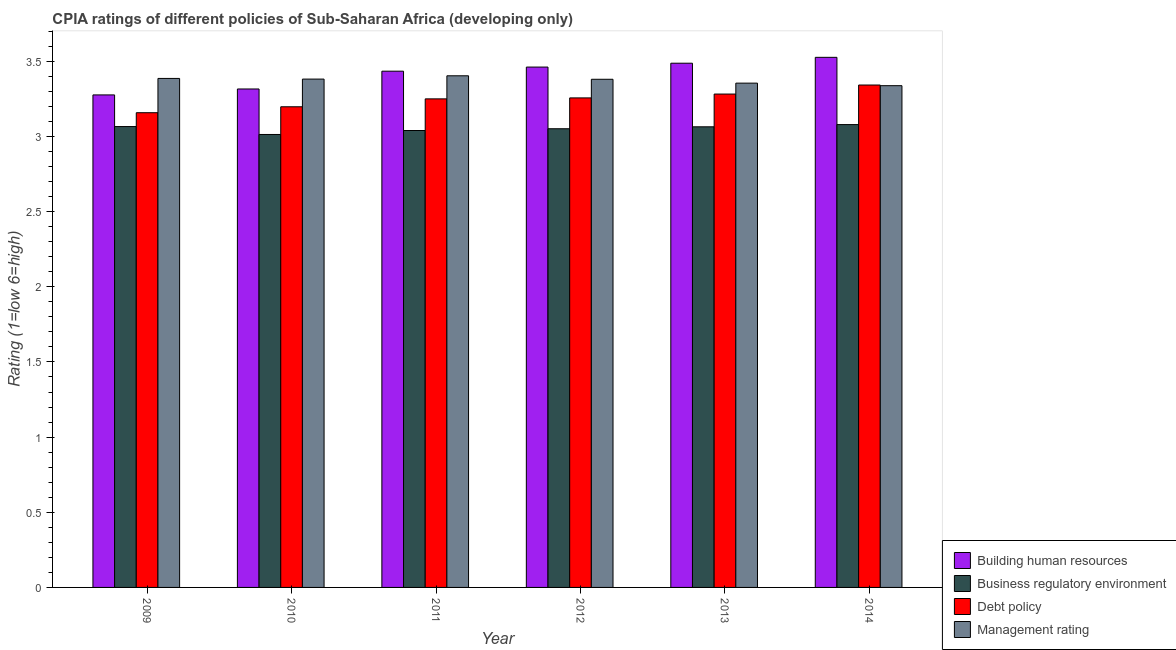How many groups of bars are there?
Provide a succinct answer. 6. Are the number of bars per tick equal to the number of legend labels?
Keep it short and to the point. Yes. How many bars are there on the 5th tick from the right?
Give a very brief answer. 4. What is the cpia rating of building human resources in 2013?
Keep it short and to the point. 3.49. Across all years, what is the maximum cpia rating of debt policy?
Provide a short and direct response. 3.34. Across all years, what is the minimum cpia rating of debt policy?
Keep it short and to the point. 3.16. In which year was the cpia rating of building human resources maximum?
Your answer should be very brief. 2014. In which year was the cpia rating of business regulatory environment minimum?
Offer a very short reply. 2010. What is the total cpia rating of debt policy in the graph?
Provide a succinct answer. 19.49. What is the difference between the cpia rating of building human resources in 2013 and that in 2014?
Keep it short and to the point. -0.04. What is the difference between the cpia rating of management in 2010 and the cpia rating of building human resources in 2011?
Your answer should be very brief. -0.02. What is the average cpia rating of business regulatory environment per year?
Give a very brief answer. 3.05. What is the ratio of the cpia rating of management in 2009 to that in 2014?
Your response must be concise. 1.01. Is the cpia rating of building human resources in 2012 less than that in 2014?
Keep it short and to the point. Yes. Is the difference between the cpia rating of building human resources in 2009 and 2014 greater than the difference between the cpia rating of business regulatory environment in 2009 and 2014?
Keep it short and to the point. No. What is the difference between the highest and the second highest cpia rating of management?
Keep it short and to the point. 0.02. What is the difference between the highest and the lowest cpia rating of debt policy?
Offer a terse response. 0.18. In how many years, is the cpia rating of management greater than the average cpia rating of management taken over all years?
Ensure brevity in your answer.  4. Is it the case that in every year, the sum of the cpia rating of business regulatory environment and cpia rating of management is greater than the sum of cpia rating of debt policy and cpia rating of building human resources?
Give a very brief answer. No. What does the 3rd bar from the left in 2013 represents?
Offer a very short reply. Debt policy. What does the 3rd bar from the right in 2011 represents?
Keep it short and to the point. Business regulatory environment. What is the difference between two consecutive major ticks on the Y-axis?
Make the answer very short. 0.5. Are the values on the major ticks of Y-axis written in scientific E-notation?
Your answer should be very brief. No. Does the graph contain any zero values?
Your answer should be very brief. No. Where does the legend appear in the graph?
Provide a short and direct response. Bottom right. What is the title of the graph?
Offer a very short reply. CPIA ratings of different policies of Sub-Saharan Africa (developing only). What is the label or title of the X-axis?
Your answer should be very brief. Year. What is the Rating (1=low 6=high) in Building human resources in 2009?
Provide a succinct answer. 3.28. What is the Rating (1=low 6=high) of Business regulatory environment in 2009?
Offer a terse response. 3.07. What is the Rating (1=low 6=high) of Debt policy in 2009?
Keep it short and to the point. 3.16. What is the Rating (1=low 6=high) of Management rating in 2009?
Make the answer very short. 3.39. What is the Rating (1=low 6=high) of Building human resources in 2010?
Make the answer very short. 3.32. What is the Rating (1=low 6=high) in Business regulatory environment in 2010?
Your response must be concise. 3.01. What is the Rating (1=low 6=high) of Debt policy in 2010?
Ensure brevity in your answer.  3.2. What is the Rating (1=low 6=high) of Management rating in 2010?
Offer a very short reply. 3.38. What is the Rating (1=low 6=high) in Building human resources in 2011?
Keep it short and to the point. 3.43. What is the Rating (1=low 6=high) in Business regulatory environment in 2011?
Offer a very short reply. 3.04. What is the Rating (1=low 6=high) in Debt policy in 2011?
Your answer should be compact. 3.25. What is the Rating (1=low 6=high) of Management rating in 2011?
Offer a very short reply. 3.4. What is the Rating (1=low 6=high) of Building human resources in 2012?
Provide a succinct answer. 3.46. What is the Rating (1=low 6=high) in Business regulatory environment in 2012?
Your response must be concise. 3.05. What is the Rating (1=low 6=high) of Debt policy in 2012?
Make the answer very short. 3.26. What is the Rating (1=low 6=high) in Management rating in 2012?
Provide a succinct answer. 3.38. What is the Rating (1=low 6=high) in Building human resources in 2013?
Your answer should be very brief. 3.49. What is the Rating (1=low 6=high) in Business regulatory environment in 2013?
Ensure brevity in your answer.  3.06. What is the Rating (1=low 6=high) in Debt policy in 2013?
Your response must be concise. 3.28. What is the Rating (1=low 6=high) in Management rating in 2013?
Ensure brevity in your answer.  3.35. What is the Rating (1=low 6=high) of Building human resources in 2014?
Keep it short and to the point. 3.53. What is the Rating (1=low 6=high) in Business regulatory environment in 2014?
Offer a very short reply. 3.08. What is the Rating (1=low 6=high) in Debt policy in 2014?
Provide a short and direct response. 3.34. What is the Rating (1=low 6=high) in Management rating in 2014?
Provide a short and direct response. 3.34. Across all years, what is the maximum Rating (1=low 6=high) in Building human resources?
Make the answer very short. 3.53. Across all years, what is the maximum Rating (1=low 6=high) in Business regulatory environment?
Your response must be concise. 3.08. Across all years, what is the maximum Rating (1=low 6=high) of Debt policy?
Keep it short and to the point. 3.34. Across all years, what is the maximum Rating (1=low 6=high) of Management rating?
Your answer should be compact. 3.4. Across all years, what is the minimum Rating (1=low 6=high) of Building human resources?
Your answer should be compact. 3.28. Across all years, what is the minimum Rating (1=low 6=high) of Business regulatory environment?
Keep it short and to the point. 3.01. Across all years, what is the minimum Rating (1=low 6=high) in Debt policy?
Give a very brief answer. 3.16. Across all years, what is the minimum Rating (1=low 6=high) in Management rating?
Make the answer very short. 3.34. What is the total Rating (1=low 6=high) of Building human resources in the graph?
Your answer should be very brief. 20.5. What is the total Rating (1=low 6=high) of Business regulatory environment in the graph?
Offer a very short reply. 18.31. What is the total Rating (1=low 6=high) of Debt policy in the graph?
Offer a terse response. 19.49. What is the total Rating (1=low 6=high) in Management rating in the graph?
Offer a terse response. 20.24. What is the difference between the Rating (1=low 6=high) in Building human resources in 2009 and that in 2010?
Ensure brevity in your answer.  -0.04. What is the difference between the Rating (1=low 6=high) of Business regulatory environment in 2009 and that in 2010?
Provide a short and direct response. 0.05. What is the difference between the Rating (1=low 6=high) of Debt policy in 2009 and that in 2010?
Ensure brevity in your answer.  -0.04. What is the difference between the Rating (1=low 6=high) of Management rating in 2009 and that in 2010?
Provide a succinct answer. 0. What is the difference between the Rating (1=low 6=high) of Building human resources in 2009 and that in 2011?
Your response must be concise. -0.16. What is the difference between the Rating (1=low 6=high) in Business regulatory environment in 2009 and that in 2011?
Your answer should be compact. 0.03. What is the difference between the Rating (1=low 6=high) in Debt policy in 2009 and that in 2011?
Offer a very short reply. -0.09. What is the difference between the Rating (1=low 6=high) of Management rating in 2009 and that in 2011?
Offer a terse response. -0.02. What is the difference between the Rating (1=low 6=high) of Building human resources in 2009 and that in 2012?
Your answer should be very brief. -0.19. What is the difference between the Rating (1=low 6=high) in Business regulatory environment in 2009 and that in 2012?
Keep it short and to the point. 0.01. What is the difference between the Rating (1=low 6=high) of Debt policy in 2009 and that in 2012?
Keep it short and to the point. -0.1. What is the difference between the Rating (1=low 6=high) of Management rating in 2009 and that in 2012?
Offer a very short reply. 0.01. What is the difference between the Rating (1=low 6=high) of Building human resources in 2009 and that in 2013?
Make the answer very short. -0.21. What is the difference between the Rating (1=low 6=high) in Business regulatory environment in 2009 and that in 2013?
Provide a succinct answer. 0. What is the difference between the Rating (1=low 6=high) in Debt policy in 2009 and that in 2013?
Ensure brevity in your answer.  -0.12. What is the difference between the Rating (1=low 6=high) of Management rating in 2009 and that in 2013?
Your answer should be very brief. 0.03. What is the difference between the Rating (1=low 6=high) of Business regulatory environment in 2009 and that in 2014?
Your answer should be compact. -0.01. What is the difference between the Rating (1=low 6=high) of Debt policy in 2009 and that in 2014?
Ensure brevity in your answer.  -0.18. What is the difference between the Rating (1=low 6=high) in Management rating in 2009 and that in 2014?
Offer a terse response. 0.05. What is the difference between the Rating (1=low 6=high) in Building human resources in 2010 and that in 2011?
Offer a terse response. -0.12. What is the difference between the Rating (1=low 6=high) of Business regulatory environment in 2010 and that in 2011?
Give a very brief answer. -0.03. What is the difference between the Rating (1=low 6=high) of Debt policy in 2010 and that in 2011?
Offer a very short reply. -0.05. What is the difference between the Rating (1=low 6=high) in Management rating in 2010 and that in 2011?
Offer a very short reply. -0.02. What is the difference between the Rating (1=low 6=high) of Building human resources in 2010 and that in 2012?
Offer a terse response. -0.15. What is the difference between the Rating (1=low 6=high) of Business regulatory environment in 2010 and that in 2012?
Give a very brief answer. -0.04. What is the difference between the Rating (1=low 6=high) in Debt policy in 2010 and that in 2012?
Your answer should be very brief. -0.06. What is the difference between the Rating (1=low 6=high) in Management rating in 2010 and that in 2012?
Ensure brevity in your answer.  0. What is the difference between the Rating (1=low 6=high) in Building human resources in 2010 and that in 2013?
Your answer should be compact. -0.17. What is the difference between the Rating (1=low 6=high) in Business regulatory environment in 2010 and that in 2013?
Give a very brief answer. -0.05. What is the difference between the Rating (1=low 6=high) of Debt policy in 2010 and that in 2013?
Your response must be concise. -0.08. What is the difference between the Rating (1=low 6=high) in Management rating in 2010 and that in 2013?
Keep it short and to the point. 0.03. What is the difference between the Rating (1=low 6=high) of Building human resources in 2010 and that in 2014?
Offer a terse response. -0.21. What is the difference between the Rating (1=low 6=high) of Business regulatory environment in 2010 and that in 2014?
Give a very brief answer. -0.07. What is the difference between the Rating (1=low 6=high) in Debt policy in 2010 and that in 2014?
Offer a very short reply. -0.14. What is the difference between the Rating (1=low 6=high) of Management rating in 2010 and that in 2014?
Keep it short and to the point. 0.04. What is the difference between the Rating (1=low 6=high) in Building human resources in 2011 and that in 2012?
Ensure brevity in your answer.  -0.03. What is the difference between the Rating (1=low 6=high) in Business regulatory environment in 2011 and that in 2012?
Your response must be concise. -0.01. What is the difference between the Rating (1=low 6=high) of Debt policy in 2011 and that in 2012?
Provide a succinct answer. -0.01. What is the difference between the Rating (1=low 6=high) of Management rating in 2011 and that in 2012?
Offer a very short reply. 0.02. What is the difference between the Rating (1=low 6=high) in Building human resources in 2011 and that in 2013?
Offer a very short reply. -0.05. What is the difference between the Rating (1=low 6=high) in Business regulatory environment in 2011 and that in 2013?
Your answer should be very brief. -0.02. What is the difference between the Rating (1=low 6=high) of Debt policy in 2011 and that in 2013?
Your answer should be very brief. -0.03. What is the difference between the Rating (1=low 6=high) in Management rating in 2011 and that in 2013?
Offer a terse response. 0.05. What is the difference between the Rating (1=low 6=high) in Building human resources in 2011 and that in 2014?
Offer a very short reply. -0.09. What is the difference between the Rating (1=low 6=high) in Business regulatory environment in 2011 and that in 2014?
Provide a short and direct response. -0.04. What is the difference between the Rating (1=low 6=high) in Debt policy in 2011 and that in 2014?
Keep it short and to the point. -0.09. What is the difference between the Rating (1=low 6=high) in Management rating in 2011 and that in 2014?
Make the answer very short. 0.07. What is the difference between the Rating (1=low 6=high) of Building human resources in 2012 and that in 2013?
Make the answer very short. -0.03. What is the difference between the Rating (1=low 6=high) of Business regulatory environment in 2012 and that in 2013?
Make the answer very short. -0.01. What is the difference between the Rating (1=low 6=high) in Debt policy in 2012 and that in 2013?
Offer a terse response. -0.03. What is the difference between the Rating (1=low 6=high) in Management rating in 2012 and that in 2013?
Provide a succinct answer. 0.03. What is the difference between the Rating (1=low 6=high) in Building human resources in 2012 and that in 2014?
Provide a short and direct response. -0.06. What is the difference between the Rating (1=low 6=high) in Business regulatory environment in 2012 and that in 2014?
Your answer should be compact. -0.03. What is the difference between the Rating (1=low 6=high) of Debt policy in 2012 and that in 2014?
Your answer should be compact. -0.09. What is the difference between the Rating (1=low 6=high) in Management rating in 2012 and that in 2014?
Keep it short and to the point. 0.04. What is the difference between the Rating (1=low 6=high) of Building human resources in 2013 and that in 2014?
Offer a terse response. -0.04. What is the difference between the Rating (1=low 6=high) of Business regulatory environment in 2013 and that in 2014?
Give a very brief answer. -0.01. What is the difference between the Rating (1=low 6=high) in Debt policy in 2013 and that in 2014?
Provide a succinct answer. -0.06. What is the difference between the Rating (1=low 6=high) in Management rating in 2013 and that in 2014?
Keep it short and to the point. 0.02. What is the difference between the Rating (1=low 6=high) in Building human resources in 2009 and the Rating (1=low 6=high) in Business regulatory environment in 2010?
Provide a short and direct response. 0.26. What is the difference between the Rating (1=low 6=high) of Building human resources in 2009 and the Rating (1=low 6=high) of Debt policy in 2010?
Provide a short and direct response. 0.08. What is the difference between the Rating (1=low 6=high) in Building human resources in 2009 and the Rating (1=low 6=high) in Management rating in 2010?
Provide a succinct answer. -0.11. What is the difference between the Rating (1=low 6=high) of Business regulatory environment in 2009 and the Rating (1=low 6=high) of Debt policy in 2010?
Offer a very short reply. -0.13. What is the difference between the Rating (1=low 6=high) in Business regulatory environment in 2009 and the Rating (1=low 6=high) in Management rating in 2010?
Your answer should be very brief. -0.32. What is the difference between the Rating (1=low 6=high) of Debt policy in 2009 and the Rating (1=low 6=high) of Management rating in 2010?
Your response must be concise. -0.22. What is the difference between the Rating (1=low 6=high) of Building human resources in 2009 and the Rating (1=low 6=high) of Business regulatory environment in 2011?
Make the answer very short. 0.24. What is the difference between the Rating (1=low 6=high) of Building human resources in 2009 and the Rating (1=low 6=high) of Debt policy in 2011?
Offer a terse response. 0.03. What is the difference between the Rating (1=low 6=high) of Building human resources in 2009 and the Rating (1=low 6=high) of Management rating in 2011?
Offer a very short reply. -0.13. What is the difference between the Rating (1=low 6=high) of Business regulatory environment in 2009 and the Rating (1=low 6=high) of Debt policy in 2011?
Provide a succinct answer. -0.18. What is the difference between the Rating (1=low 6=high) in Business regulatory environment in 2009 and the Rating (1=low 6=high) in Management rating in 2011?
Provide a succinct answer. -0.34. What is the difference between the Rating (1=low 6=high) in Debt policy in 2009 and the Rating (1=low 6=high) in Management rating in 2011?
Offer a very short reply. -0.25. What is the difference between the Rating (1=low 6=high) of Building human resources in 2009 and the Rating (1=low 6=high) of Business regulatory environment in 2012?
Provide a short and direct response. 0.23. What is the difference between the Rating (1=low 6=high) in Building human resources in 2009 and the Rating (1=low 6=high) in Debt policy in 2012?
Give a very brief answer. 0.02. What is the difference between the Rating (1=low 6=high) in Building human resources in 2009 and the Rating (1=low 6=high) in Management rating in 2012?
Provide a short and direct response. -0.1. What is the difference between the Rating (1=low 6=high) in Business regulatory environment in 2009 and the Rating (1=low 6=high) in Debt policy in 2012?
Offer a terse response. -0.19. What is the difference between the Rating (1=low 6=high) in Business regulatory environment in 2009 and the Rating (1=low 6=high) in Management rating in 2012?
Ensure brevity in your answer.  -0.31. What is the difference between the Rating (1=low 6=high) in Debt policy in 2009 and the Rating (1=low 6=high) in Management rating in 2012?
Provide a succinct answer. -0.22. What is the difference between the Rating (1=low 6=high) of Building human resources in 2009 and the Rating (1=low 6=high) of Business regulatory environment in 2013?
Provide a short and direct response. 0.21. What is the difference between the Rating (1=low 6=high) in Building human resources in 2009 and the Rating (1=low 6=high) in Debt policy in 2013?
Offer a terse response. -0.01. What is the difference between the Rating (1=low 6=high) in Building human resources in 2009 and the Rating (1=low 6=high) in Management rating in 2013?
Offer a terse response. -0.08. What is the difference between the Rating (1=low 6=high) of Business regulatory environment in 2009 and the Rating (1=low 6=high) of Debt policy in 2013?
Make the answer very short. -0.22. What is the difference between the Rating (1=low 6=high) in Business regulatory environment in 2009 and the Rating (1=low 6=high) in Management rating in 2013?
Ensure brevity in your answer.  -0.29. What is the difference between the Rating (1=low 6=high) in Debt policy in 2009 and the Rating (1=low 6=high) in Management rating in 2013?
Ensure brevity in your answer.  -0.2. What is the difference between the Rating (1=low 6=high) in Building human resources in 2009 and the Rating (1=low 6=high) in Business regulatory environment in 2014?
Your response must be concise. 0.2. What is the difference between the Rating (1=low 6=high) of Building human resources in 2009 and the Rating (1=low 6=high) of Debt policy in 2014?
Provide a succinct answer. -0.07. What is the difference between the Rating (1=low 6=high) in Building human resources in 2009 and the Rating (1=low 6=high) in Management rating in 2014?
Provide a succinct answer. -0.06. What is the difference between the Rating (1=low 6=high) of Business regulatory environment in 2009 and the Rating (1=low 6=high) of Debt policy in 2014?
Your response must be concise. -0.28. What is the difference between the Rating (1=low 6=high) of Business regulatory environment in 2009 and the Rating (1=low 6=high) of Management rating in 2014?
Your answer should be very brief. -0.27. What is the difference between the Rating (1=low 6=high) of Debt policy in 2009 and the Rating (1=low 6=high) of Management rating in 2014?
Your answer should be very brief. -0.18. What is the difference between the Rating (1=low 6=high) in Building human resources in 2010 and the Rating (1=low 6=high) in Business regulatory environment in 2011?
Keep it short and to the point. 0.28. What is the difference between the Rating (1=low 6=high) of Building human resources in 2010 and the Rating (1=low 6=high) of Debt policy in 2011?
Give a very brief answer. 0.07. What is the difference between the Rating (1=low 6=high) in Building human resources in 2010 and the Rating (1=low 6=high) in Management rating in 2011?
Make the answer very short. -0.09. What is the difference between the Rating (1=low 6=high) of Business regulatory environment in 2010 and the Rating (1=low 6=high) of Debt policy in 2011?
Your answer should be very brief. -0.24. What is the difference between the Rating (1=low 6=high) in Business regulatory environment in 2010 and the Rating (1=low 6=high) in Management rating in 2011?
Offer a very short reply. -0.39. What is the difference between the Rating (1=low 6=high) of Debt policy in 2010 and the Rating (1=low 6=high) of Management rating in 2011?
Ensure brevity in your answer.  -0.21. What is the difference between the Rating (1=low 6=high) of Building human resources in 2010 and the Rating (1=low 6=high) of Business regulatory environment in 2012?
Ensure brevity in your answer.  0.26. What is the difference between the Rating (1=low 6=high) of Building human resources in 2010 and the Rating (1=low 6=high) of Debt policy in 2012?
Offer a terse response. 0.06. What is the difference between the Rating (1=low 6=high) in Building human resources in 2010 and the Rating (1=low 6=high) in Management rating in 2012?
Give a very brief answer. -0.06. What is the difference between the Rating (1=low 6=high) of Business regulatory environment in 2010 and the Rating (1=low 6=high) of Debt policy in 2012?
Offer a very short reply. -0.24. What is the difference between the Rating (1=low 6=high) of Business regulatory environment in 2010 and the Rating (1=low 6=high) of Management rating in 2012?
Your answer should be very brief. -0.37. What is the difference between the Rating (1=low 6=high) of Debt policy in 2010 and the Rating (1=low 6=high) of Management rating in 2012?
Ensure brevity in your answer.  -0.18. What is the difference between the Rating (1=low 6=high) of Building human resources in 2010 and the Rating (1=low 6=high) of Business regulatory environment in 2013?
Provide a succinct answer. 0.25. What is the difference between the Rating (1=low 6=high) in Building human resources in 2010 and the Rating (1=low 6=high) in Debt policy in 2013?
Make the answer very short. 0.03. What is the difference between the Rating (1=low 6=high) in Building human resources in 2010 and the Rating (1=low 6=high) in Management rating in 2013?
Provide a short and direct response. -0.04. What is the difference between the Rating (1=low 6=high) of Business regulatory environment in 2010 and the Rating (1=low 6=high) of Debt policy in 2013?
Offer a very short reply. -0.27. What is the difference between the Rating (1=low 6=high) of Business regulatory environment in 2010 and the Rating (1=low 6=high) of Management rating in 2013?
Keep it short and to the point. -0.34. What is the difference between the Rating (1=low 6=high) of Debt policy in 2010 and the Rating (1=low 6=high) of Management rating in 2013?
Keep it short and to the point. -0.16. What is the difference between the Rating (1=low 6=high) of Building human resources in 2010 and the Rating (1=low 6=high) of Business regulatory environment in 2014?
Offer a very short reply. 0.24. What is the difference between the Rating (1=low 6=high) in Building human resources in 2010 and the Rating (1=low 6=high) in Debt policy in 2014?
Keep it short and to the point. -0.03. What is the difference between the Rating (1=low 6=high) in Building human resources in 2010 and the Rating (1=low 6=high) in Management rating in 2014?
Offer a terse response. -0.02. What is the difference between the Rating (1=low 6=high) in Business regulatory environment in 2010 and the Rating (1=low 6=high) in Debt policy in 2014?
Provide a short and direct response. -0.33. What is the difference between the Rating (1=low 6=high) in Business regulatory environment in 2010 and the Rating (1=low 6=high) in Management rating in 2014?
Your answer should be compact. -0.32. What is the difference between the Rating (1=low 6=high) in Debt policy in 2010 and the Rating (1=low 6=high) in Management rating in 2014?
Ensure brevity in your answer.  -0.14. What is the difference between the Rating (1=low 6=high) of Building human resources in 2011 and the Rating (1=low 6=high) of Business regulatory environment in 2012?
Keep it short and to the point. 0.38. What is the difference between the Rating (1=low 6=high) of Building human resources in 2011 and the Rating (1=low 6=high) of Debt policy in 2012?
Your answer should be very brief. 0.18. What is the difference between the Rating (1=low 6=high) of Building human resources in 2011 and the Rating (1=low 6=high) of Management rating in 2012?
Offer a terse response. 0.05. What is the difference between the Rating (1=low 6=high) of Business regulatory environment in 2011 and the Rating (1=low 6=high) of Debt policy in 2012?
Keep it short and to the point. -0.22. What is the difference between the Rating (1=low 6=high) in Business regulatory environment in 2011 and the Rating (1=low 6=high) in Management rating in 2012?
Provide a short and direct response. -0.34. What is the difference between the Rating (1=low 6=high) in Debt policy in 2011 and the Rating (1=low 6=high) in Management rating in 2012?
Offer a terse response. -0.13. What is the difference between the Rating (1=low 6=high) in Building human resources in 2011 and the Rating (1=low 6=high) in Business regulatory environment in 2013?
Your answer should be compact. 0.37. What is the difference between the Rating (1=low 6=high) of Building human resources in 2011 and the Rating (1=low 6=high) of Debt policy in 2013?
Your response must be concise. 0.15. What is the difference between the Rating (1=low 6=high) of Building human resources in 2011 and the Rating (1=low 6=high) of Management rating in 2013?
Provide a short and direct response. 0.08. What is the difference between the Rating (1=low 6=high) in Business regulatory environment in 2011 and the Rating (1=low 6=high) in Debt policy in 2013?
Give a very brief answer. -0.24. What is the difference between the Rating (1=low 6=high) in Business regulatory environment in 2011 and the Rating (1=low 6=high) in Management rating in 2013?
Your answer should be very brief. -0.32. What is the difference between the Rating (1=low 6=high) in Debt policy in 2011 and the Rating (1=low 6=high) in Management rating in 2013?
Your answer should be very brief. -0.1. What is the difference between the Rating (1=low 6=high) in Building human resources in 2011 and the Rating (1=low 6=high) in Business regulatory environment in 2014?
Offer a very short reply. 0.36. What is the difference between the Rating (1=low 6=high) in Building human resources in 2011 and the Rating (1=low 6=high) in Debt policy in 2014?
Provide a succinct answer. 0.09. What is the difference between the Rating (1=low 6=high) of Building human resources in 2011 and the Rating (1=low 6=high) of Management rating in 2014?
Your answer should be compact. 0.1. What is the difference between the Rating (1=low 6=high) in Business regulatory environment in 2011 and the Rating (1=low 6=high) in Debt policy in 2014?
Offer a very short reply. -0.3. What is the difference between the Rating (1=low 6=high) of Business regulatory environment in 2011 and the Rating (1=low 6=high) of Management rating in 2014?
Provide a succinct answer. -0.3. What is the difference between the Rating (1=low 6=high) in Debt policy in 2011 and the Rating (1=low 6=high) in Management rating in 2014?
Offer a terse response. -0.09. What is the difference between the Rating (1=low 6=high) of Building human resources in 2012 and the Rating (1=low 6=high) of Business regulatory environment in 2013?
Your answer should be very brief. 0.4. What is the difference between the Rating (1=low 6=high) of Building human resources in 2012 and the Rating (1=low 6=high) of Debt policy in 2013?
Offer a terse response. 0.18. What is the difference between the Rating (1=low 6=high) of Building human resources in 2012 and the Rating (1=low 6=high) of Management rating in 2013?
Your response must be concise. 0.11. What is the difference between the Rating (1=low 6=high) in Business regulatory environment in 2012 and the Rating (1=low 6=high) in Debt policy in 2013?
Your answer should be compact. -0.23. What is the difference between the Rating (1=low 6=high) in Business regulatory environment in 2012 and the Rating (1=low 6=high) in Management rating in 2013?
Ensure brevity in your answer.  -0.3. What is the difference between the Rating (1=low 6=high) of Debt policy in 2012 and the Rating (1=low 6=high) of Management rating in 2013?
Your answer should be compact. -0.1. What is the difference between the Rating (1=low 6=high) of Building human resources in 2012 and the Rating (1=low 6=high) of Business regulatory environment in 2014?
Provide a short and direct response. 0.38. What is the difference between the Rating (1=low 6=high) of Building human resources in 2012 and the Rating (1=low 6=high) of Debt policy in 2014?
Your response must be concise. 0.12. What is the difference between the Rating (1=low 6=high) in Building human resources in 2012 and the Rating (1=low 6=high) in Management rating in 2014?
Make the answer very short. 0.12. What is the difference between the Rating (1=low 6=high) of Business regulatory environment in 2012 and the Rating (1=low 6=high) of Debt policy in 2014?
Give a very brief answer. -0.29. What is the difference between the Rating (1=low 6=high) in Business regulatory environment in 2012 and the Rating (1=low 6=high) in Management rating in 2014?
Offer a terse response. -0.29. What is the difference between the Rating (1=low 6=high) of Debt policy in 2012 and the Rating (1=low 6=high) of Management rating in 2014?
Your answer should be very brief. -0.08. What is the difference between the Rating (1=low 6=high) in Building human resources in 2013 and the Rating (1=low 6=high) in Business regulatory environment in 2014?
Provide a succinct answer. 0.41. What is the difference between the Rating (1=low 6=high) of Building human resources in 2013 and the Rating (1=low 6=high) of Debt policy in 2014?
Provide a short and direct response. 0.15. What is the difference between the Rating (1=low 6=high) in Building human resources in 2013 and the Rating (1=low 6=high) in Management rating in 2014?
Your answer should be compact. 0.15. What is the difference between the Rating (1=low 6=high) in Business regulatory environment in 2013 and the Rating (1=low 6=high) in Debt policy in 2014?
Offer a terse response. -0.28. What is the difference between the Rating (1=low 6=high) in Business regulatory environment in 2013 and the Rating (1=low 6=high) in Management rating in 2014?
Keep it short and to the point. -0.27. What is the difference between the Rating (1=low 6=high) in Debt policy in 2013 and the Rating (1=low 6=high) in Management rating in 2014?
Offer a very short reply. -0.06. What is the average Rating (1=low 6=high) of Building human resources per year?
Make the answer very short. 3.42. What is the average Rating (1=low 6=high) in Business regulatory environment per year?
Offer a very short reply. 3.05. What is the average Rating (1=low 6=high) in Debt policy per year?
Provide a succinct answer. 3.25. What is the average Rating (1=low 6=high) of Management rating per year?
Make the answer very short. 3.37. In the year 2009, what is the difference between the Rating (1=low 6=high) of Building human resources and Rating (1=low 6=high) of Business regulatory environment?
Ensure brevity in your answer.  0.21. In the year 2009, what is the difference between the Rating (1=low 6=high) of Building human resources and Rating (1=low 6=high) of Debt policy?
Provide a short and direct response. 0.12. In the year 2009, what is the difference between the Rating (1=low 6=high) of Building human resources and Rating (1=low 6=high) of Management rating?
Your response must be concise. -0.11. In the year 2009, what is the difference between the Rating (1=low 6=high) in Business regulatory environment and Rating (1=low 6=high) in Debt policy?
Your answer should be very brief. -0.09. In the year 2009, what is the difference between the Rating (1=low 6=high) of Business regulatory environment and Rating (1=low 6=high) of Management rating?
Give a very brief answer. -0.32. In the year 2009, what is the difference between the Rating (1=low 6=high) of Debt policy and Rating (1=low 6=high) of Management rating?
Give a very brief answer. -0.23. In the year 2010, what is the difference between the Rating (1=low 6=high) of Building human resources and Rating (1=low 6=high) of Business regulatory environment?
Provide a succinct answer. 0.3. In the year 2010, what is the difference between the Rating (1=low 6=high) in Building human resources and Rating (1=low 6=high) in Debt policy?
Your response must be concise. 0.12. In the year 2010, what is the difference between the Rating (1=low 6=high) of Building human resources and Rating (1=low 6=high) of Management rating?
Provide a short and direct response. -0.07. In the year 2010, what is the difference between the Rating (1=low 6=high) of Business regulatory environment and Rating (1=low 6=high) of Debt policy?
Make the answer very short. -0.18. In the year 2010, what is the difference between the Rating (1=low 6=high) in Business regulatory environment and Rating (1=low 6=high) in Management rating?
Offer a terse response. -0.37. In the year 2010, what is the difference between the Rating (1=low 6=high) in Debt policy and Rating (1=low 6=high) in Management rating?
Your answer should be very brief. -0.18. In the year 2011, what is the difference between the Rating (1=low 6=high) in Building human resources and Rating (1=low 6=high) in Business regulatory environment?
Make the answer very short. 0.39. In the year 2011, what is the difference between the Rating (1=low 6=high) in Building human resources and Rating (1=low 6=high) in Debt policy?
Give a very brief answer. 0.18. In the year 2011, what is the difference between the Rating (1=low 6=high) of Building human resources and Rating (1=low 6=high) of Management rating?
Keep it short and to the point. 0.03. In the year 2011, what is the difference between the Rating (1=low 6=high) in Business regulatory environment and Rating (1=low 6=high) in Debt policy?
Provide a short and direct response. -0.21. In the year 2011, what is the difference between the Rating (1=low 6=high) of Business regulatory environment and Rating (1=low 6=high) of Management rating?
Keep it short and to the point. -0.36. In the year 2011, what is the difference between the Rating (1=low 6=high) in Debt policy and Rating (1=low 6=high) in Management rating?
Provide a succinct answer. -0.15. In the year 2012, what is the difference between the Rating (1=low 6=high) in Building human resources and Rating (1=low 6=high) in Business regulatory environment?
Your response must be concise. 0.41. In the year 2012, what is the difference between the Rating (1=low 6=high) of Building human resources and Rating (1=low 6=high) of Debt policy?
Make the answer very short. 0.21. In the year 2012, what is the difference between the Rating (1=low 6=high) in Building human resources and Rating (1=low 6=high) in Management rating?
Give a very brief answer. 0.08. In the year 2012, what is the difference between the Rating (1=low 6=high) of Business regulatory environment and Rating (1=low 6=high) of Debt policy?
Keep it short and to the point. -0.21. In the year 2012, what is the difference between the Rating (1=low 6=high) in Business regulatory environment and Rating (1=low 6=high) in Management rating?
Keep it short and to the point. -0.33. In the year 2012, what is the difference between the Rating (1=low 6=high) in Debt policy and Rating (1=low 6=high) in Management rating?
Make the answer very short. -0.12. In the year 2013, what is the difference between the Rating (1=low 6=high) of Building human resources and Rating (1=low 6=high) of Business regulatory environment?
Provide a short and direct response. 0.42. In the year 2013, what is the difference between the Rating (1=low 6=high) of Building human resources and Rating (1=low 6=high) of Debt policy?
Provide a succinct answer. 0.21. In the year 2013, what is the difference between the Rating (1=low 6=high) in Building human resources and Rating (1=low 6=high) in Management rating?
Provide a short and direct response. 0.13. In the year 2013, what is the difference between the Rating (1=low 6=high) of Business regulatory environment and Rating (1=low 6=high) of Debt policy?
Offer a very short reply. -0.22. In the year 2013, what is the difference between the Rating (1=low 6=high) of Business regulatory environment and Rating (1=low 6=high) of Management rating?
Make the answer very short. -0.29. In the year 2013, what is the difference between the Rating (1=low 6=high) in Debt policy and Rating (1=low 6=high) in Management rating?
Offer a terse response. -0.07. In the year 2014, what is the difference between the Rating (1=low 6=high) of Building human resources and Rating (1=low 6=high) of Business regulatory environment?
Provide a short and direct response. 0.45. In the year 2014, what is the difference between the Rating (1=low 6=high) of Building human resources and Rating (1=low 6=high) of Debt policy?
Provide a succinct answer. 0.18. In the year 2014, what is the difference between the Rating (1=low 6=high) in Building human resources and Rating (1=low 6=high) in Management rating?
Provide a short and direct response. 0.19. In the year 2014, what is the difference between the Rating (1=low 6=high) of Business regulatory environment and Rating (1=low 6=high) of Debt policy?
Make the answer very short. -0.26. In the year 2014, what is the difference between the Rating (1=low 6=high) in Business regulatory environment and Rating (1=low 6=high) in Management rating?
Give a very brief answer. -0.26. In the year 2014, what is the difference between the Rating (1=low 6=high) of Debt policy and Rating (1=low 6=high) of Management rating?
Your response must be concise. 0. What is the ratio of the Rating (1=low 6=high) of Business regulatory environment in 2009 to that in 2010?
Give a very brief answer. 1.02. What is the ratio of the Rating (1=low 6=high) in Debt policy in 2009 to that in 2010?
Keep it short and to the point. 0.99. What is the ratio of the Rating (1=low 6=high) of Management rating in 2009 to that in 2010?
Ensure brevity in your answer.  1. What is the ratio of the Rating (1=low 6=high) in Building human resources in 2009 to that in 2011?
Make the answer very short. 0.95. What is the ratio of the Rating (1=low 6=high) of Business regulatory environment in 2009 to that in 2011?
Give a very brief answer. 1.01. What is the ratio of the Rating (1=low 6=high) of Debt policy in 2009 to that in 2011?
Provide a short and direct response. 0.97. What is the ratio of the Rating (1=low 6=high) in Building human resources in 2009 to that in 2012?
Keep it short and to the point. 0.95. What is the ratio of the Rating (1=low 6=high) of Business regulatory environment in 2009 to that in 2012?
Offer a terse response. 1. What is the ratio of the Rating (1=low 6=high) in Debt policy in 2009 to that in 2012?
Offer a terse response. 0.97. What is the ratio of the Rating (1=low 6=high) in Building human resources in 2009 to that in 2013?
Offer a very short reply. 0.94. What is the ratio of the Rating (1=low 6=high) of Business regulatory environment in 2009 to that in 2013?
Your response must be concise. 1. What is the ratio of the Rating (1=low 6=high) of Debt policy in 2009 to that in 2013?
Provide a short and direct response. 0.96. What is the ratio of the Rating (1=low 6=high) in Management rating in 2009 to that in 2013?
Offer a terse response. 1.01. What is the ratio of the Rating (1=low 6=high) in Building human resources in 2009 to that in 2014?
Offer a very short reply. 0.93. What is the ratio of the Rating (1=low 6=high) of Business regulatory environment in 2009 to that in 2014?
Make the answer very short. 1. What is the ratio of the Rating (1=low 6=high) of Debt policy in 2009 to that in 2014?
Keep it short and to the point. 0.94. What is the ratio of the Rating (1=low 6=high) of Management rating in 2009 to that in 2014?
Your response must be concise. 1.01. What is the ratio of the Rating (1=low 6=high) in Building human resources in 2010 to that in 2011?
Provide a succinct answer. 0.97. What is the ratio of the Rating (1=low 6=high) in Business regulatory environment in 2010 to that in 2011?
Ensure brevity in your answer.  0.99. What is the ratio of the Rating (1=low 6=high) in Debt policy in 2010 to that in 2011?
Offer a terse response. 0.98. What is the ratio of the Rating (1=low 6=high) in Building human resources in 2010 to that in 2012?
Offer a very short reply. 0.96. What is the ratio of the Rating (1=low 6=high) of Business regulatory environment in 2010 to that in 2012?
Offer a terse response. 0.99. What is the ratio of the Rating (1=low 6=high) in Debt policy in 2010 to that in 2012?
Offer a terse response. 0.98. What is the ratio of the Rating (1=low 6=high) in Management rating in 2010 to that in 2012?
Offer a terse response. 1. What is the ratio of the Rating (1=low 6=high) in Building human resources in 2010 to that in 2013?
Your response must be concise. 0.95. What is the ratio of the Rating (1=low 6=high) of Business regulatory environment in 2010 to that in 2013?
Your answer should be very brief. 0.98. What is the ratio of the Rating (1=low 6=high) in Debt policy in 2010 to that in 2013?
Keep it short and to the point. 0.97. What is the ratio of the Rating (1=low 6=high) in Management rating in 2010 to that in 2013?
Offer a terse response. 1.01. What is the ratio of the Rating (1=low 6=high) of Building human resources in 2010 to that in 2014?
Provide a succinct answer. 0.94. What is the ratio of the Rating (1=low 6=high) of Business regulatory environment in 2010 to that in 2014?
Give a very brief answer. 0.98. What is the ratio of the Rating (1=low 6=high) of Debt policy in 2010 to that in 2014?
Offer a very short reply. 0.96. What is the ratio of the Rating (1=low 6=high) in Management rating in 2010 to that in 2014?
Give a very brief answer. 1.01. What is the ratio of the Rating (1=low 6=high) in Building human resources in 2011 to that in 2012?
Provide a short and direct response. 0.99. What is the ratio of the Rating (1=low 6=high) in Debt policy in 2011 to that in 2012?
Offer a very short reply. 1. What is the ratio of the Rating (1=low 6=high) of Building human resources in 2011 to that in 2013?
Give a very brief answer. 0.98. What is the ratio of the Rating (1=low 6=high) in Business regulatory environment in 2011 to that in 2013?
Your answer should be very brief. 0.99. What is the ratio of the Rating (1=low 6=high) of Debt policy in 2011 to that in 2013?
Offer a very short reply. 0.99. What is the ratio of the Rating (1=low 6=high) in Management rating in 2011 to that in 2013?
Offer a terse response. 1.01. What is the ratio of the Rating (1=low 6=high) of Building human resources in 2011 to that in 2014?
Your answer should be compact. 0.97. What is the ratio of the Rating (1=low 6=high) of Business regulatory environment in 2011 to that in 2014?
Make the answer very short. 0.99. What is the ratio of the Rating (1=low 6=high) in Debt policy in 2011 to that in 2014?
Provide a short and direct response. 0.97. What is the ratio of the Rating (1=low 6=high) of Management rating in 2011 to that in 2014?
Provide a short and direct response. 1.02. What is the ratio of the Rating (1=low 6=high) in Building human resources in 2012 to that in 2013?
Ensure brevity in your answer.  0.99. What is the ratio of the Rating (1=low 6=high) in Debt policy in 2012 to that in 2013?
Your response must be concise. 0.99. What is the ratio of the Rating (1=low 6=high) in Management rating in 2012 to that in 2013?
Your answer should be compact. 1.01. What is the ratio of the Rating (1=low 6=high) in Building human resources in 2012 to that in 2014?
Offer a very short reply. 0.98. What is the ratio of the Rating (1=low 6=high) in Business regulatory environment in 2012 to that in 2014?
Make the answer very short. 0.99. What is the ratio of the Rating (1=low 6=high) of Debt policy in 2012 to that in 2014?
Offer a very short reply. 0.97. What is the ratio of the Rating (1=low 6=high) in Management rating in 2012 to that in 2014?
Your response must be concise. 1.01. What is the ratio of the Rating (1=low 6=high) in Building human resources in 2013 to that in 2014?
Give a very brief answer. 0.99. What is the ratio of the Rating (1=low 6=high) in Debt policy in 2013 to that in 2014?
Make the answer very short. 0.98. What is the ratio of the Rating (1=low 6=high) in Management rating in 2013 to that in 2014?
Offer a terse response. 1.01. What is the difference between the highest and the second highest Rating (1=low 6=high) of Building human resources?
Ensure brevity in your answer.  0.04. What is the difference between the highest and the second highest Rating (1=low 6=high) in Business regulatory environment?
Offer a terse response. 0.01. What is the difference between the highest and the second highest Rating (1=low 6=high) in Debt policy?
Provide a succinct answer. 0.06. What is the difference between the highest and the second highest Rating (1=low 6=high) in Management rating?
Offer a terse response. 0.02. What is the difference between the highest and the lowest Rating (1=low 6=high) of Business regulatory environment?
Make the answer very short. 0.07. What is the difference between the highest and the lowest Rating (1=low 6=high) of Debt policy?
Offer a terse response. 0.18. What is the difference between the highest and the lowest Rating (1=low 6=high) of Management rating?
Offer a very short reply. 0.07. 